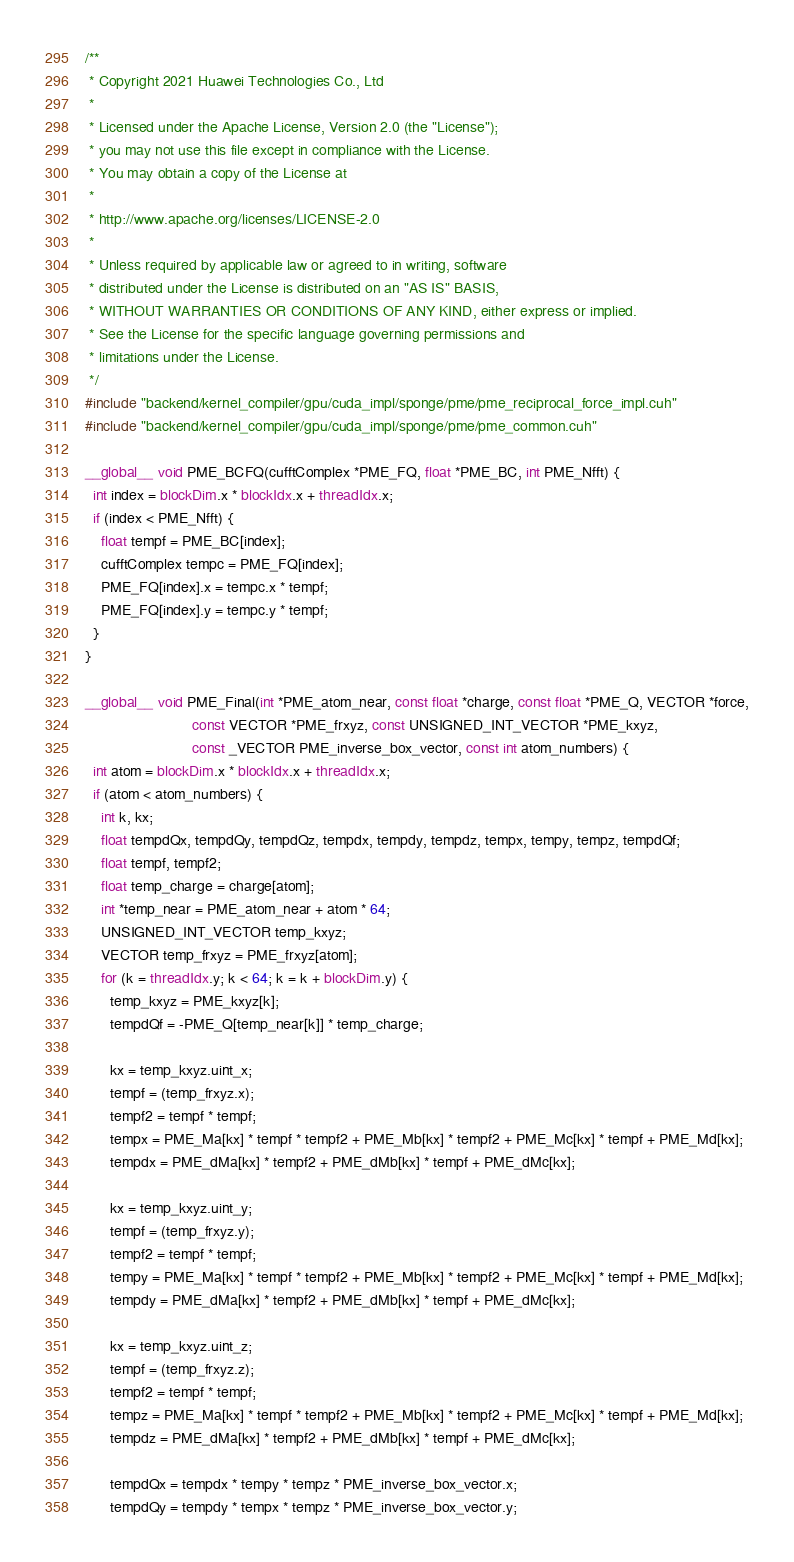<code> <loc_0><loc_0><loc_500><loc_500><_Cuda_>/**
 * Copyright 2021 Huawei Technologies Co., Ltd
 *
 * Licensed under the Apache License, Version 2.0 (the "License");
 * you may not use this file except in compliance with the License.
 * You may obtain a copy of the License at
 *
 * http://www.apache.org/licenses/LICENSE-2.0
 *
 * Unless required by applicable law or agreed to in writing, software
 * distributed under the License is distributed on an "AS IS" BASIS,
 * WITHOUT WARRANTIES OR CONDITIONS OF ANY KIND, either express or implied.
 * See the License for the specific language governing permissions and
 * limitations under the License.
 */
#include "backend/kernel_compiler/gpu/cuda_impl/sponge/pme/pme_reciprocal_force_impl.cuh"
#include "backend/kernel_compiler/gpu/cuda_impl/sponge/pme/pme_common.cuh"

__global__ void PME_BCFQ(cufftComplex *PME_FQ, float *PME_BC, int PME_Nfft) {
  int index = blockDim.x * blockIdx.x + threadIdx.x;
  if (index < PME_Nfft) {
    float tempf = PME_BC[index];
    cufftComplex tempc = PME_FQ[index];
    PME_FQ[index].x = tempc.x * tempf;
    PME_FQ[index].y = tempc.y * tempf;
  }
}

__global__ void PME_Final(int *PME_atom_near, const float *charge, const float *PME_Q, VECTOR *force,
                          const VECTOR *PME_frxyz, const UNSIGNED_INT_VECTOR *PME_kxyz,
                          const _VECTOR PME_inverse_box_vector, const int atom_numbers) {
  int atom = blockDim.x * blockIdx.x + threadIdx.x;
  if (atom < atom_numbers) {
    int k, kx;
    float tempdQx, tempdQy, tempdQz, tempdx, tempdy, tempdz, tempx, tempy, tempz, tempdQf;
    float tempf, tempf2;
    float temp_charge = charge[atom];
    int *temp_near = PME_atom_near + atom * 64;
    UNSIGNED_INT_VECTOR temp_kxyz;
    VECTOR temp_frxyz = PME_frxyz[atom];
    for (k = threadIdx.y; k < 64; k = k + blockDim.y) {
      temp_kxyz = PME_kxyz[k];
      tempdQf = -PME_Q[temp_near[k]] * temp_charge;

      kx = temp_kxyz.uint_x;
      tempf = (temp_frxyz.x);
      tempf2 = tempf * tempf;
      tempx = PME_Ma[kx] * tempf * tempf2 + PME_Mb[kx] * tempf2 + PME_Mc[kx] * tempf + PME_Md[kx];
      tempdx = PME_dMa[kx] * tempf2 + PME_dMb[kx] * tempf + PME_dMc[kx];

      kx = temp_kxyz.uint_y;
      tempf = (temp_frxyz.y);
      tempf2 = tempf * tempf;
      tempy = PME_Ma[kx] * tempf * tempf2 + PME_Mb[kx] * tempf2 + PME_Mc[kx] * tempf + PME_Md[kx];
      tempdy = PME_dMa[kx] * tempf2 + PME_dMb[kx] * tempf + PME_dMc[kx];

      kx = temp_kxyz.uint_z;
      tempf = (temp_frxyz.z);
      tempf2 = tempf * tempf;
      tempz = PME_Ma[kx] * tempf * tempf2 + PME_Mb[kx] * tempf2 + PME_Mc[kx] * tempf + PME_Md[kx];
      tempdz = PME_dMa[kx] * tempf2 + PME_dMb[kx] * tempf + PME_dMc[kx];

      tempdQx = tempdx * tempy * tempz * PME_inverse_box_vector.x;
      tempdQy = tempdy * tempx * tempz * PME_inverse_box_vector.y;</code> 